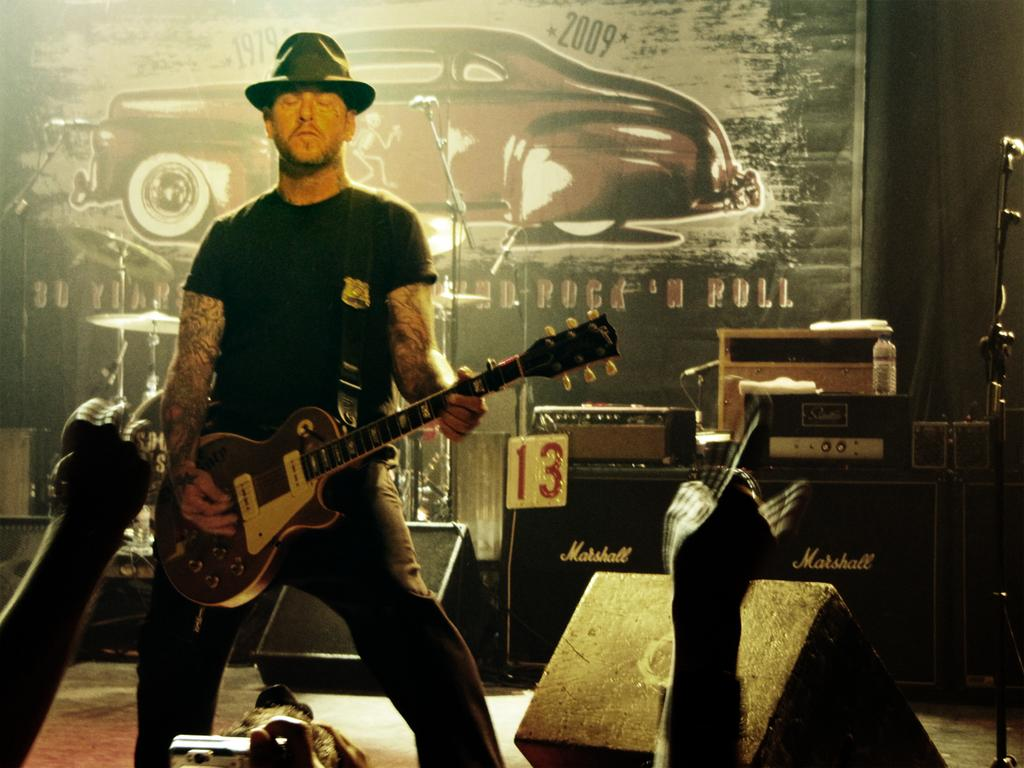What is the man in the image doing? The man is playing a guitar in the image. What other objects are related to the man's activity in the image? There are musical instruments in the image. What type of berry can be seen growing on the guitar in the image? There are no berries present on the guitar in the image; it is a musical instrument being played by the man. 